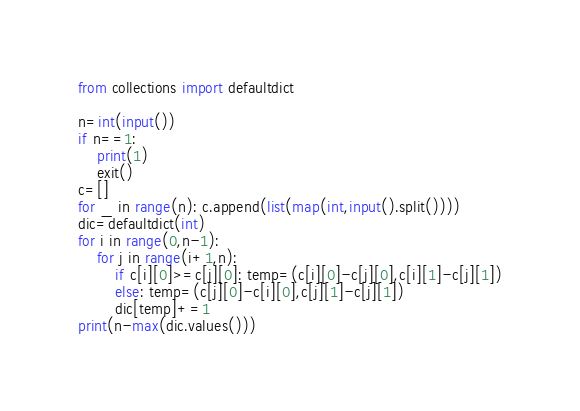<code> <loc_0><loc_0><loc_500><loc_500><_Python_>from collections import defaultdict

n=int(input())
if n==1:
    print(1)
    exit()
c=[]
for _ in range(n): c.append(list(map(int,input().split())))
dic=defaultdict(int)
for i in range(0,n-1):
    for j in range(i+1,n):
        if c[i][0]>=c[j][0]: temp=(c[i][0]-c[j][0],c[i][1]-c[j][1])
        else: temp=(c[j][0]-c[i][0],c[j][1]-c[j][1])
        dic[temp]+=1
print(n-max(dic.values()))</code> 